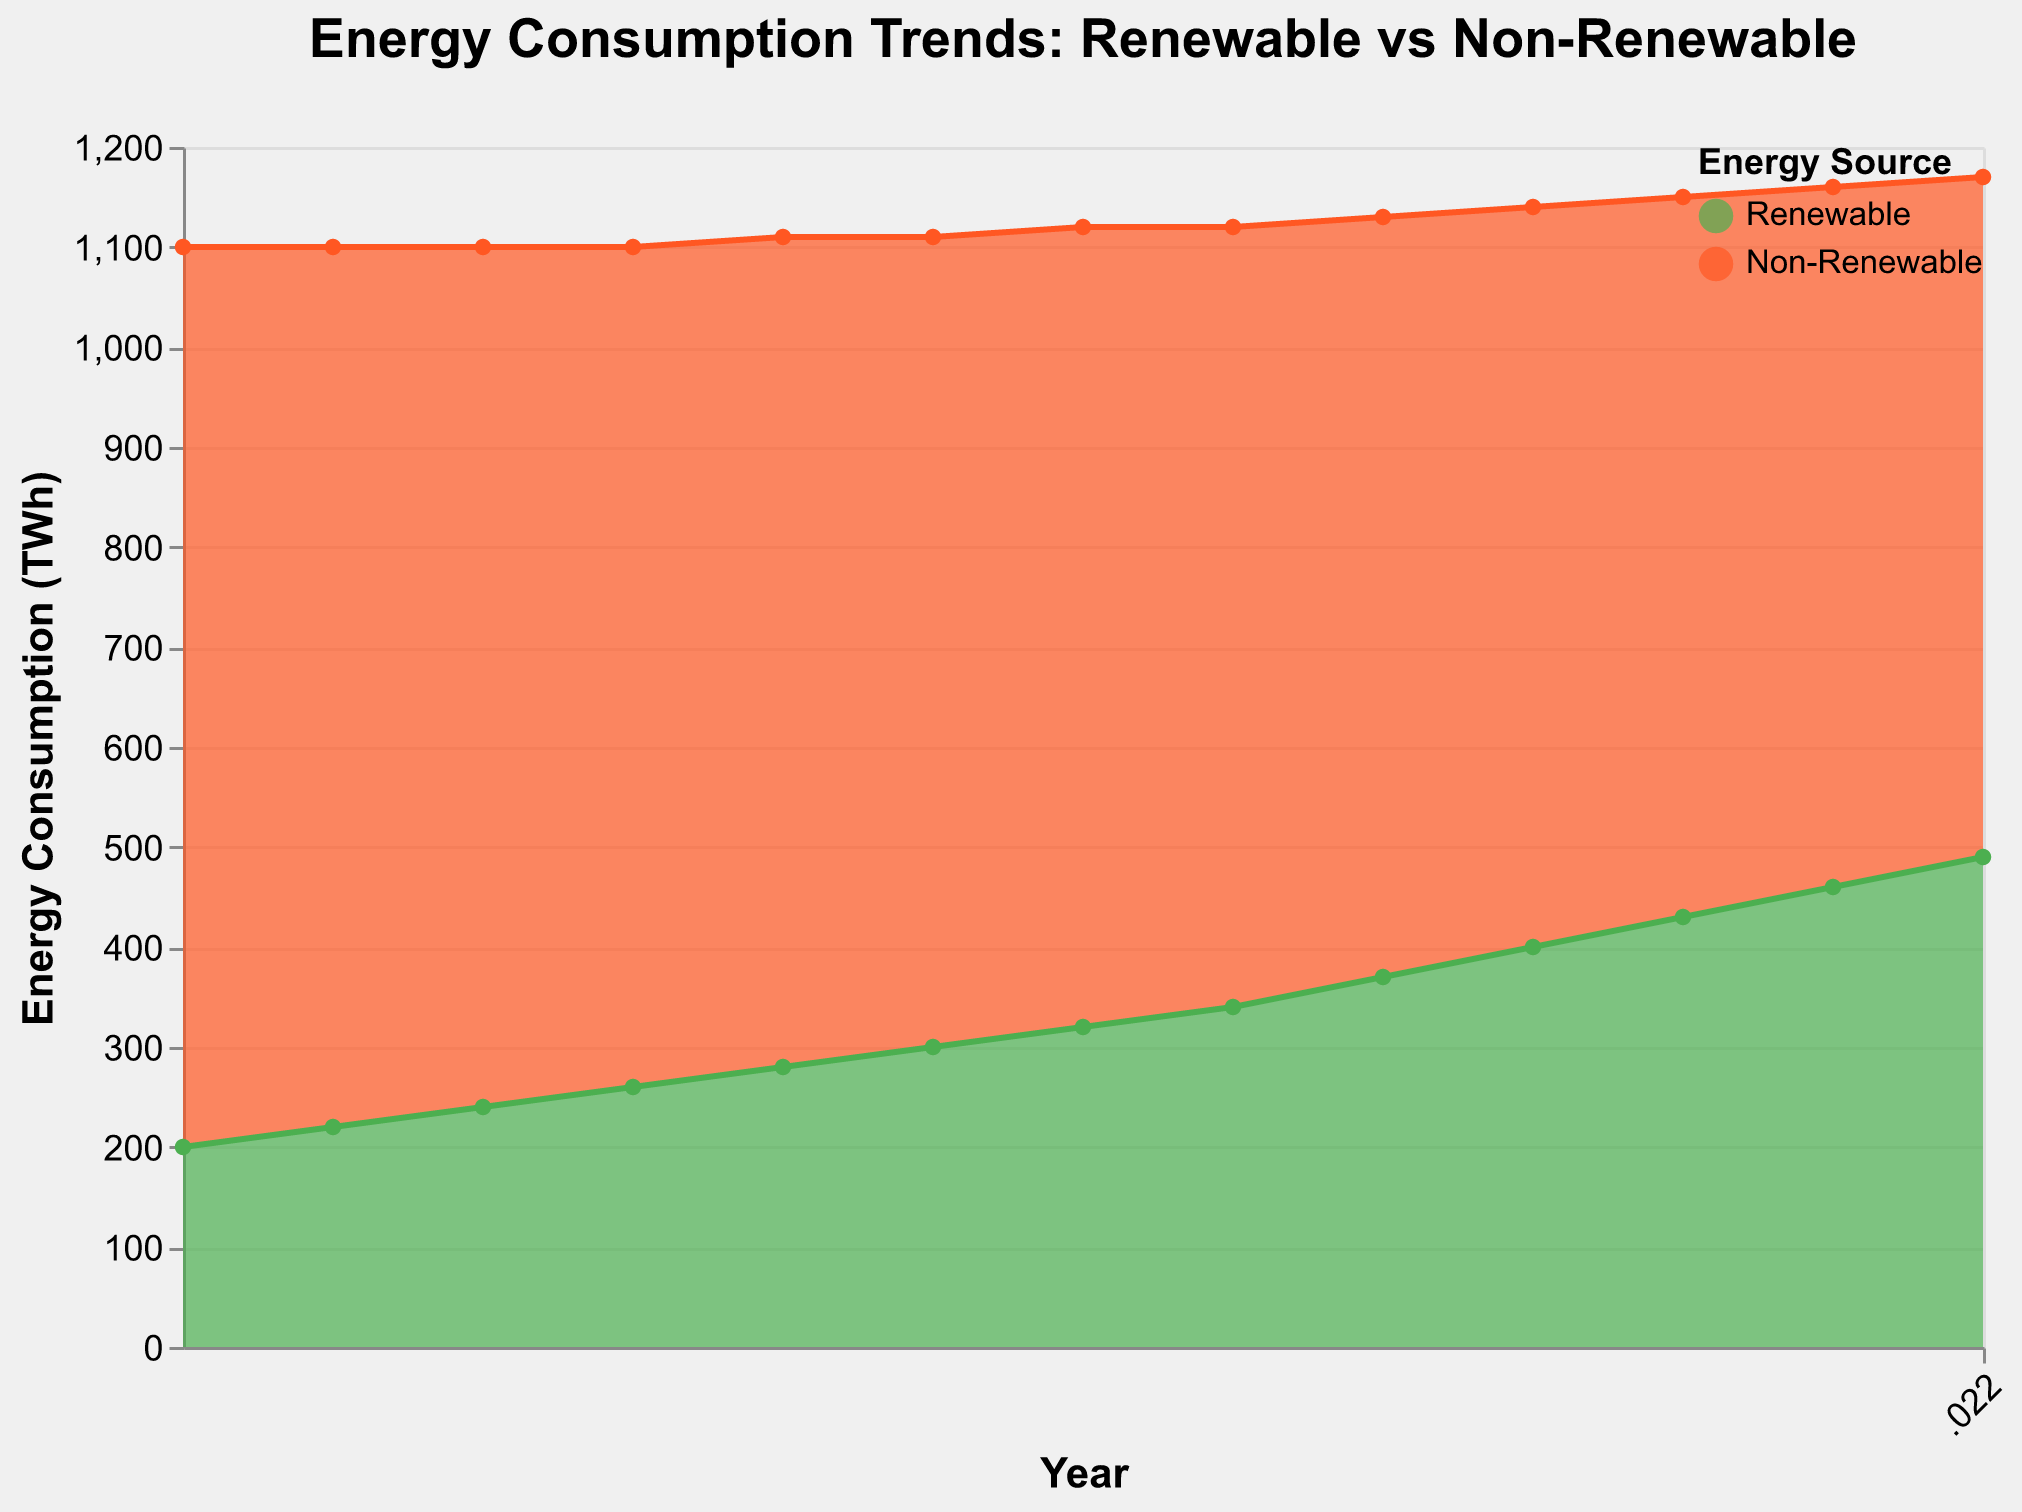What's the title of the chart? The title is usually a prominent text at the top of the chart. From the provided code, the title reads, "Energy Consumption Trends: Renewable vs Non-Renewable"
Answer: Energy Consumption Trends: Renewable vs Non-Renewable What is the consumption of renewable energy in 2013? Look at the area marked for Renewable energy (likely in green) and find the point where the year is 2013. The tooltip or data label indicates that the consumption is 260 TWh
Answer: 260 TWh How has the total energy consumption changed from 2010 to 2022? Total energy consumption is the sum of renewable and non-renewable sources. For 2010, it's 200 + 900 = 1100 TWh. For 2022, it's 490 + 680 = 1170 TWh. Comparing the two totals: 1170 TWh - 1100 TWh = 70 TWh increase
Answer: Increased by 70 TWh Which year shows the highest consumption of non-renewable energy? Analyze the non-renewable portion (likely in orange) for each year. The years earlier in the range likely have higher values. 2010 shows the highest consumption at 900 TWh
Answer: 2010 How do renewable and non-renewable energy consumptions compare in 2022? For 2022, refer to the respective areas. Renewable energy is at 490 TWh and non-renewable energy is at 680 TWh. Non-renewable energy (680 TWh) is higher than renewable energy (490 TWh)
Answer: Non-Renewable is higher What's the overall trend of renewable energy consumption over the years? Evaluate the renewable energy section from 2010 to 2022. Identify the general direction of the line or area. Renewable energy consumption shows a consistent upward trend from 200 TWh to 490 TWh
Answer: Increasing trend During which year did the difference between renewable and non-renewable energy consumption narrow the most? Calculate the yearly differences and look for the year with the smallest difference: 
For 2022: 680 - 490 = 190 TWh.
For 2021: 700 - 460 = 240 TWh.
2022 has the smallest difference, 190 TWh
Answer: 2022 Which year has the closest energy consumption between renewable and non-renewable? Compare all years and look for the smallest difference. Based on data, 2022 has the closest values with renewable at 490 TWh and non-renewable at 680 TWh. The difference is 190 TWh
Answer: 2022 What was the total energy consumption in the year with the lowest renewable energy consumption? Identify the lowest year for renewable consumption (2010, 200 TWh). Sum the consumption of both sources: 200 TWh (renewable) + 900 TWh (non-renewable) = 1100 TWh
Answer: 1100 TWh From the chart, which energy source has seen a more significant change in consumption? Compare the changes in both energy sources from 2010 to 2022. Renewable changes from 200 TWh to 490 TWh (290 TWh increase). Non-renewable changes from 900 TWh to 680 TWh (220 TWh decrease). Renewable change is more significant
Answer: Renewable energy 